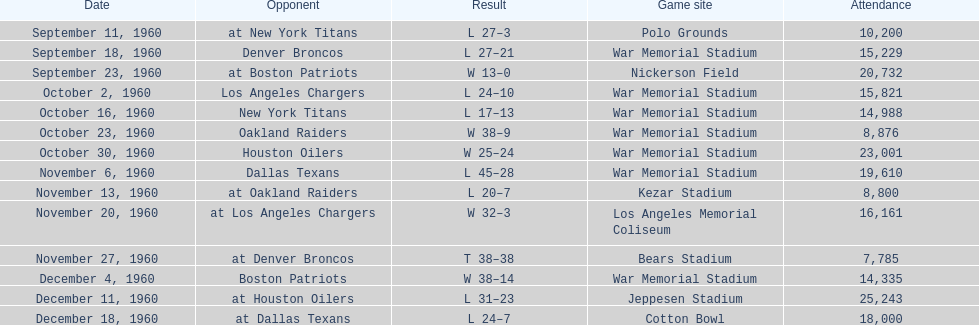How many games had at least 10,000 people in attendance? 11. 